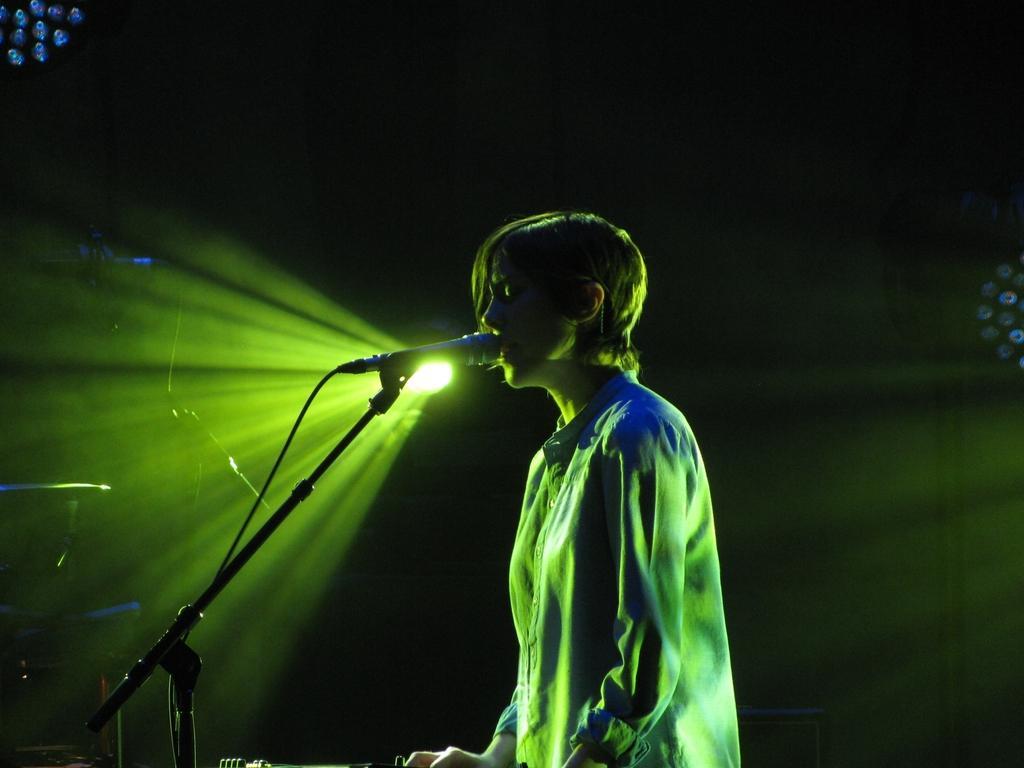Can you describe this image briefly? In this picture I can see a person standing, there is a mike with a mike stand, and in the background there are focus lights and some other objects. 